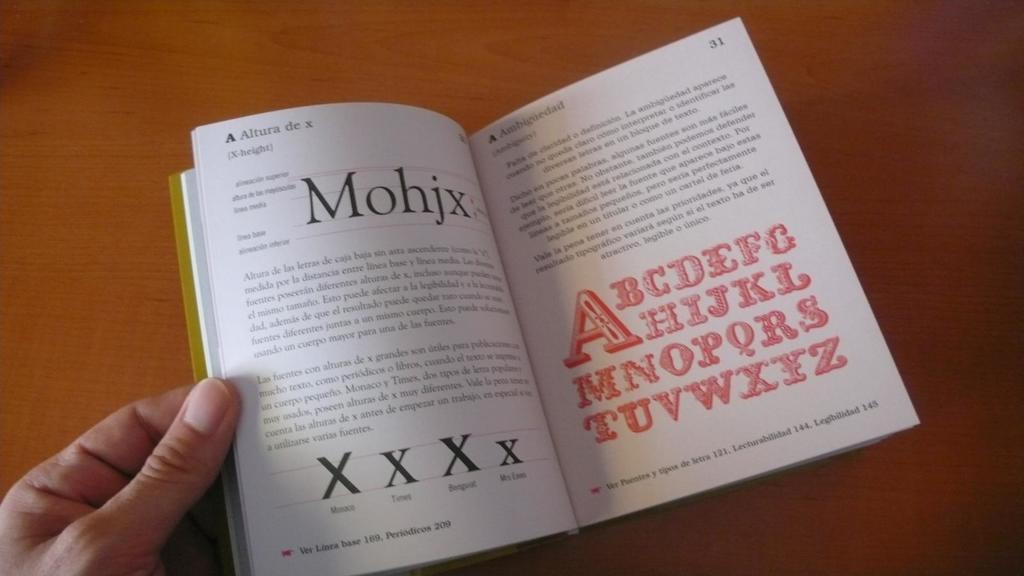Provide a one-sentence caption for the provided image. A book is open to page 31, which has the English alphabet written in red. 